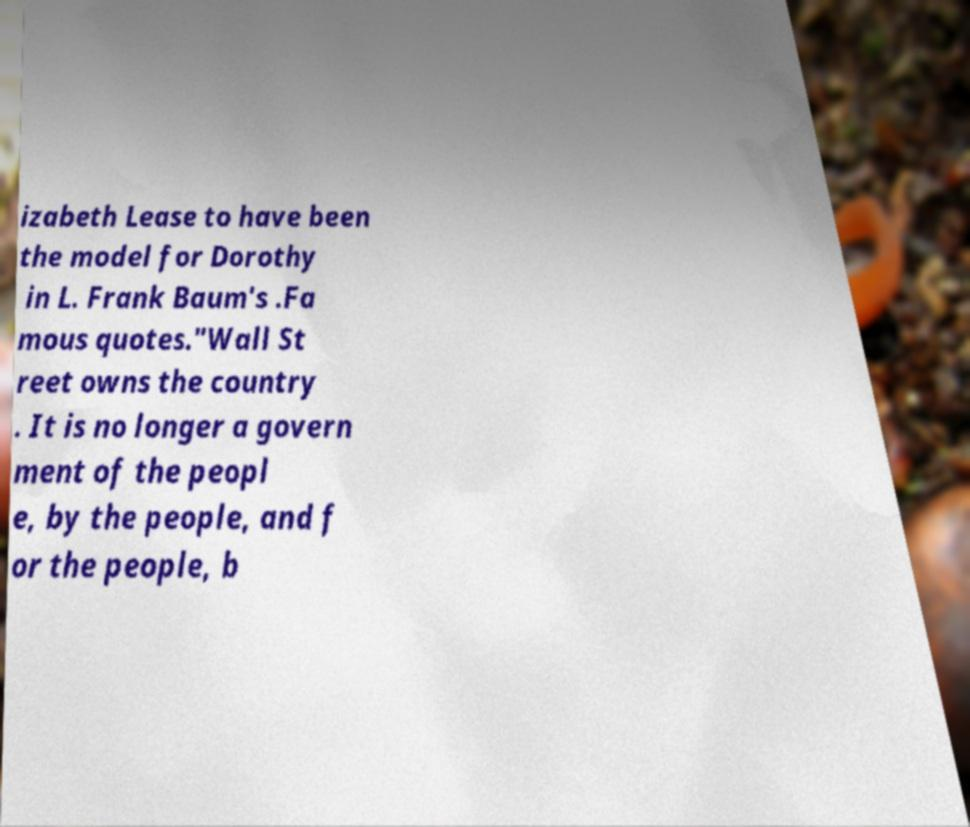Can you accurately transcribe the text from the provided image for me? izabeth Lease to have been the model for Dorothy in L. Frank Baum's .Fa mous quotes."Wall St reet owns the country . It is no longer a govern ment of the peopl e, by the people, and f or the people, b 